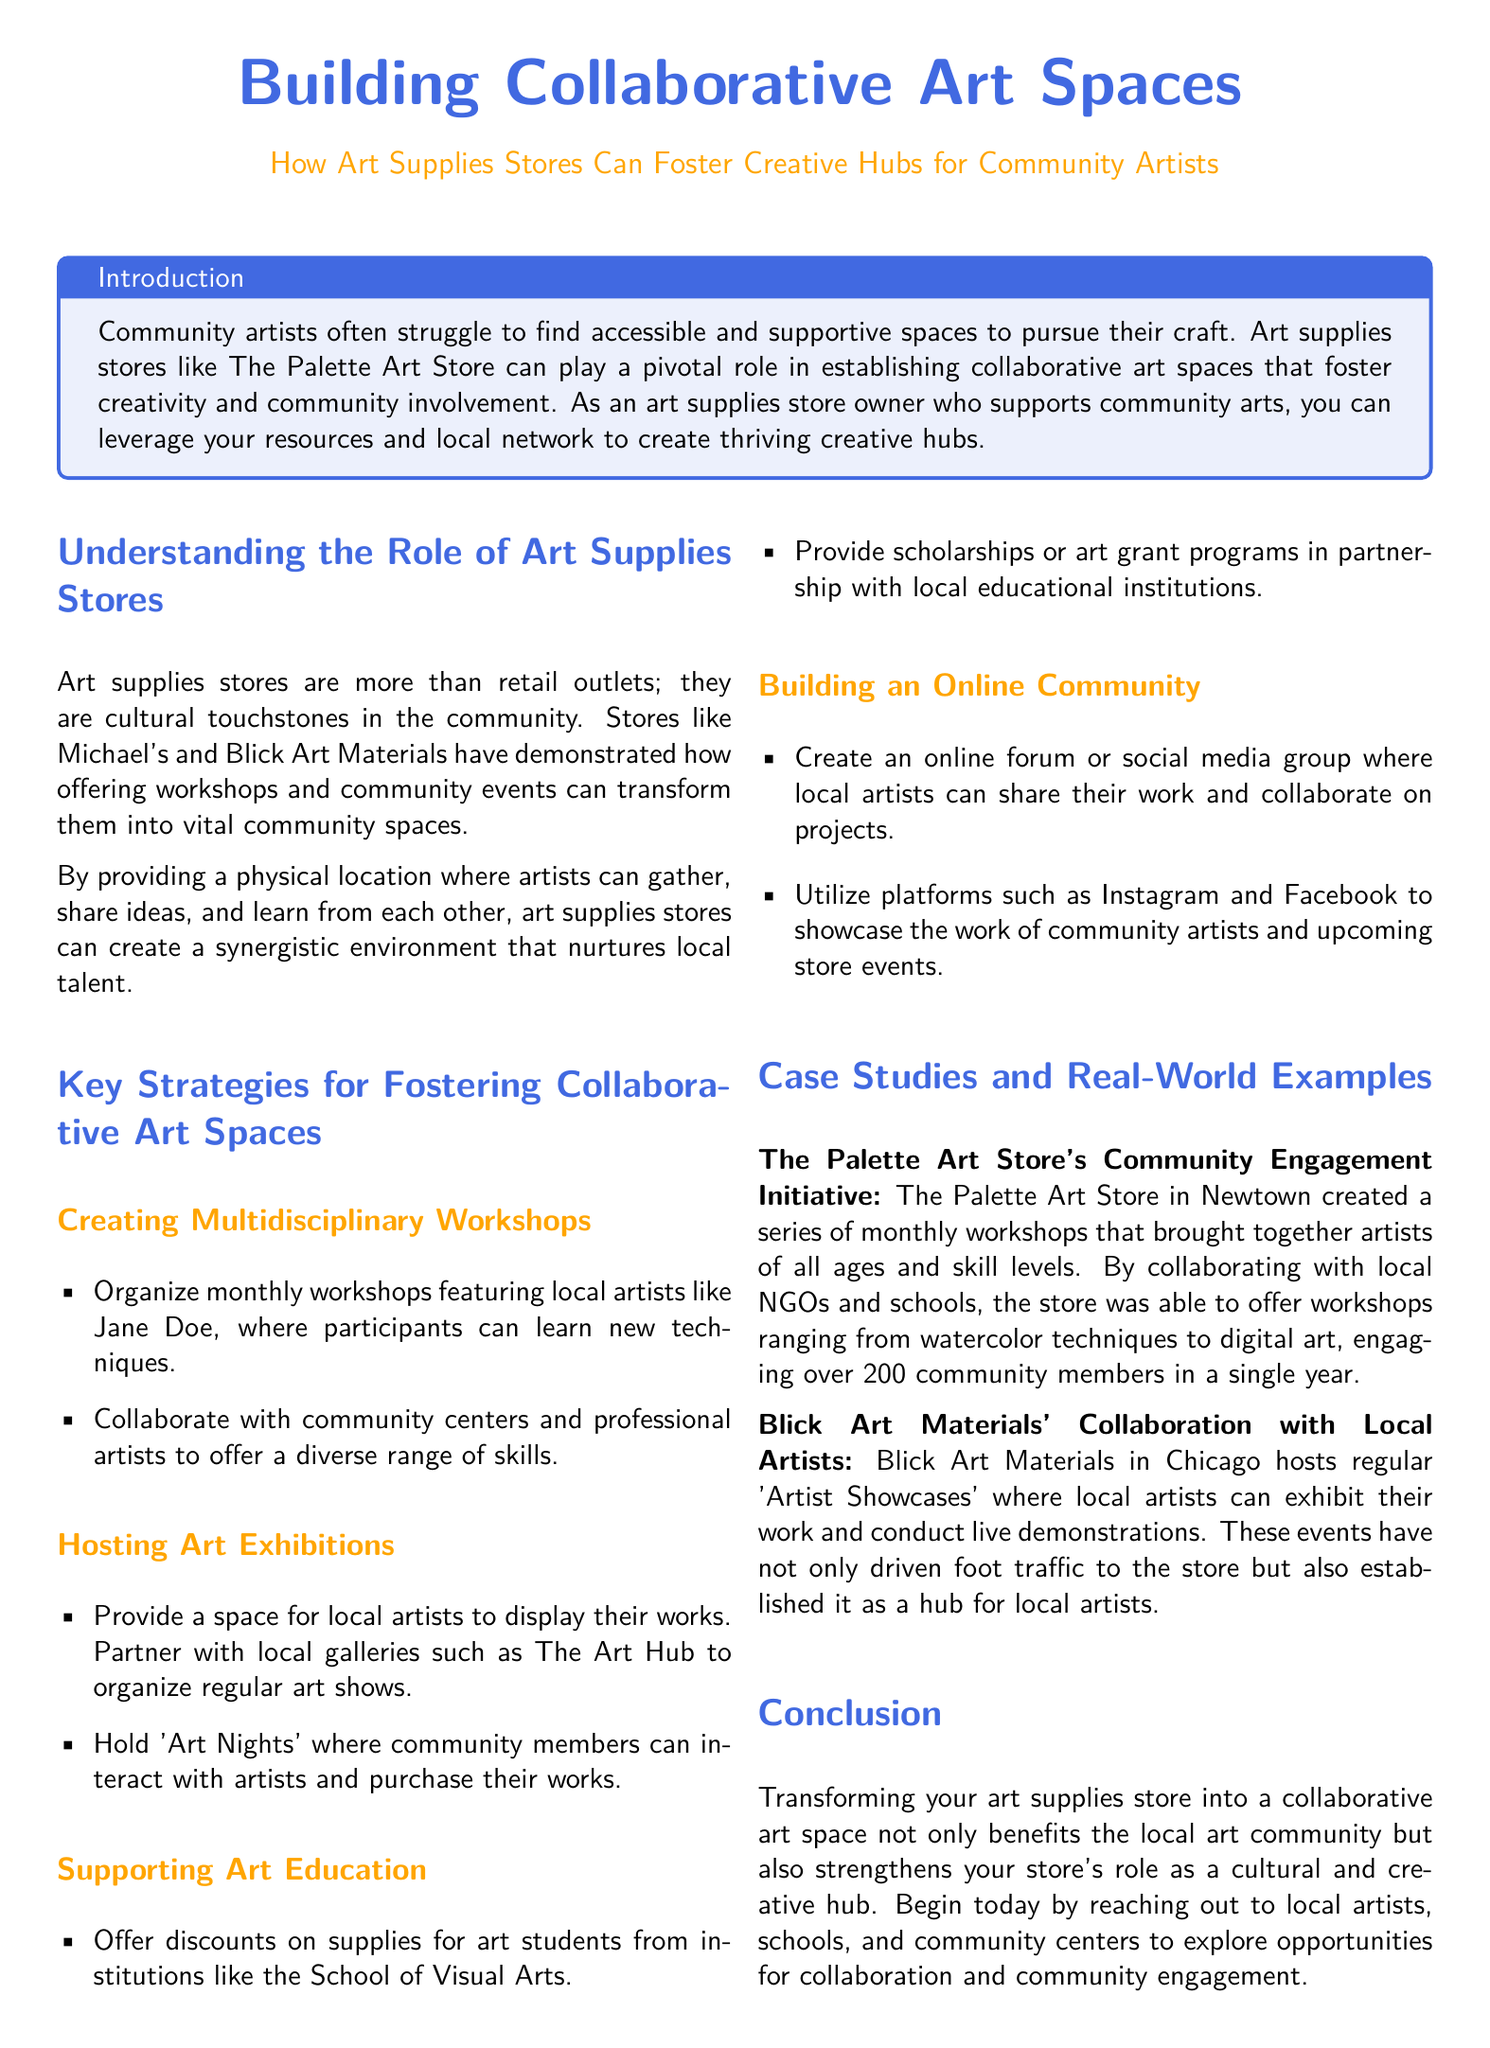What is the main purpose of the document? The document discusses how art supplies stores can establish collaborative art spaces that support community artists.
Answer: Collaborative art spaces How many community members engaged in workshops at The Palette Art Store? The document states that over 200 community members engaged in workshops over a year.
Answer: 200 What type of events did Blick Art Materials host? The document mentions that Blick Art Materials hosts 'Artist Showcases'.
Answer: Artist Showcases What is one strategy for fostering collaborative art spaces mentioned in the document? The document lists several strategies, one of which is creating multidisciplinary workshops.
Answer: Multidisciplinary workshops Which local organization is mentioned in connection with supporting art education? The document mentions partnering with local educational institutions to support art education.
Answer: educational institutions What is the color theme of the document title? The title uses the maincolor for its theme, which is RGB 65,105,225.
Answer: RGB 65,105,225 What type of workshops does the document suggest organizing? The document suggests organizing monthly workshops featuring local artists.
Answer: Monthly workshops Name one benefit of transforming an art supplies store into a collaborative art space. The document states that it strengthens the store's role as a cultural and creative hub.
Answer: Cultural and creative hub 